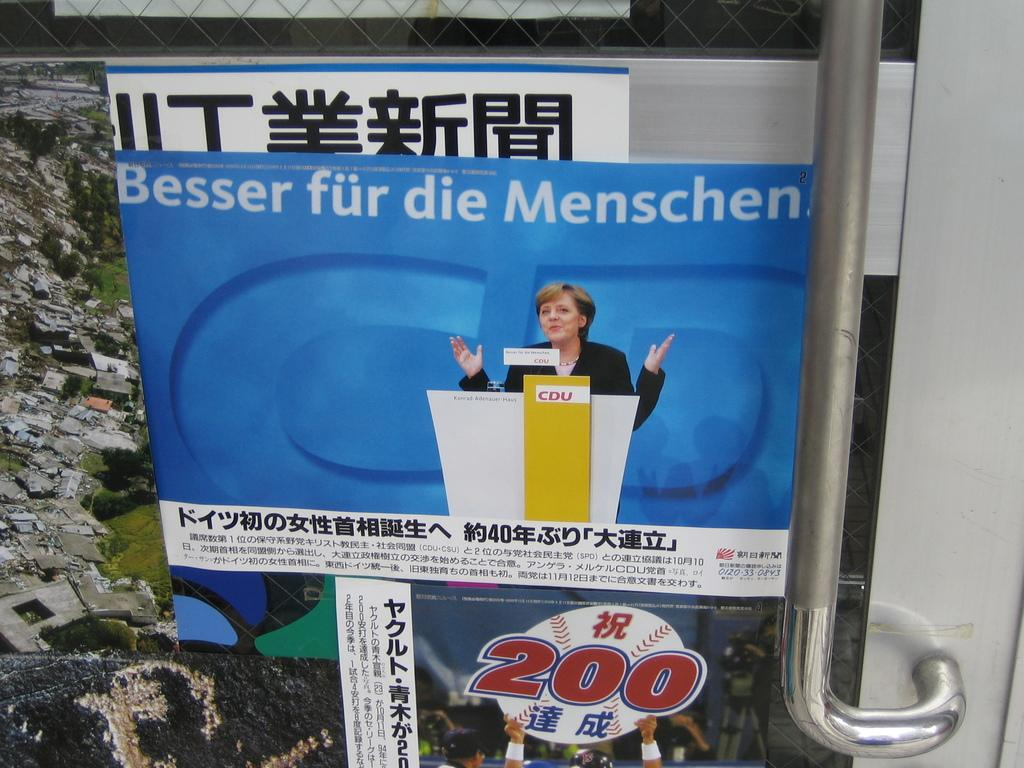Provide a one-sentence caption for the provided image. An Asian language poster contains a baseball image with the number 200 over it. 